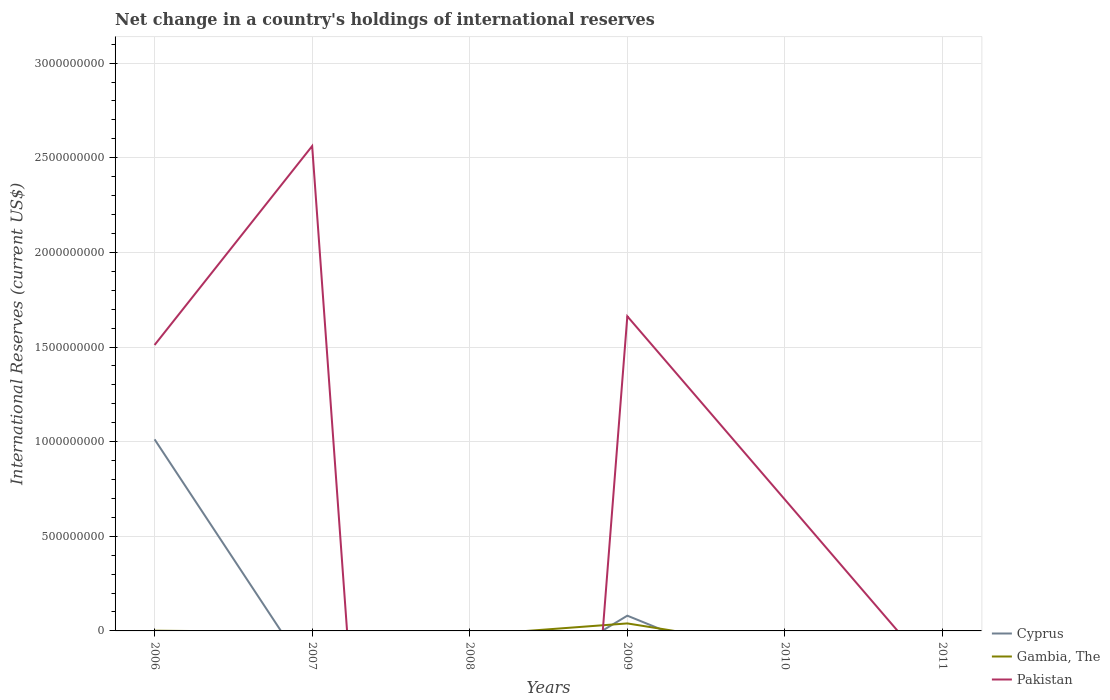Is the number of lines equal to the number of legend labels?
Provide a succinct answer. No. Across all years, what is the maximum international reserves in Pakistan?
Provide a succinct answer. 0. What is the total international reserves in Pakistan in the graph?
Provide a short and direct response. 1.87e+09. What is the difference between the highest and the second highest international reserves in Cyprus?
Your response must be concise. 1.01e+09. What is the difference between the highest and the lowest international reserves in Pakistan?
Your answer should be very brief. 3. Is the international reserves in Gambia, The strictly greater than the international reserves in Cyprus over the years?
Give a very brief answer. No. Does the graph contain any zero values?
Make the answer very short. Yes. How many legend labels are there?
Your answer should be compact. 3. How are the legend labels stacked?
Offer a very short reply. Vertical. What is the title of the graph?
Your response must be concise. Net change in a country's holdings of international reserves. Does "Congo (Democratic)" appear as one of the legend labels in the graph?
Your answer should be compact. No. What is the label or title of the X-axis?
Provide a short and direct response. Years. What is the label or title of the Y-axis?
Ensure brevity in your answer.  International Reserves (current US$). What is the International Reserves (current US$) in Cyprus in 2006?
Offer a terse response. 1.01e+09. What is the International Reserves (current US$) of Gambia, The in 2006?
Your response must be concise. 1.14e+06. What is the International Reserves (current US$) of Pakistan in 2006?
Your answer should be compact. 1.51e+09. What is the International Reserves (current US$) in Cyprus in 2007?
Provide a succinct answer. 0. What is the International Reserves (current US$) of Gambia, The in 2007?
Give a very brief answer. 0. What is the International Reserves (current US$) in Pakistan in 2007?
Your response must be concise. 2.56e+09. What is the International Reserves (current US$) of Cyprus in 2009?
Offer a very short reply. 8.05e+07. What is the International Reserves (current US$) in Gambia, The in 2009?
Ensure brevity in your answer.  3.96e+07. What is the International Reserves (current US$) of Pakistan in 2009?
Your answer should be very brief. 1.66e+09. What is the International Reserves (current US$) in Cyprus in 2010?
Keep it short and to the point. 0. What is the International Reserves (current US$) of Pakistan in 2010?
Ensure brevity in your answer.  6.94e+08. What is the International Reserves (current US$) of Cyprus in 2011?
Your response must be concise. 0. What is the International Reserves (current US$) of Gambia, The in 2011?
Offer a very short reply. 0. Across all years, what is the maximum International Reserves (current US$) in Cyprus?
Keep it short and to the point. 1.01e+09. Across all years, what is the maximum International Reserves (current US$) in Gambia, The?
Offer a very short reply. 3.96e+07. Across all years, what is the maximum International Reserves (current US$) in Pakistan?
Provide a succinct answer. 2.56e+09. Across all years, what is the minimum International Reserves (current US$) of Cyprus?
Offer a very short reply. 0. Across all years, what is the minimum International Reserves (current US$) in Pakistan?
Your answer should be compact. 0. What is the total International Reserves (current US$) in Cyprus in the graph?
Your answer should be compact. 1.09e+09. What is the total International Reserves (current US$) of Gambia, The in the graph?
Ensure brevity in your answer.  4.07e+07. What is the total International Reserves (current US$) of Pakistan in the graph?
Ensure brevity in your answer.  6.43e+09. What is the difference between the International Reserves (current US$) in Pakistan in 2006 and that in 2007?
Offer a terse response. -1.05e+09. What is the difference between the International Reserves (current US$) of Cyprus in 2006 and that in 2009?
Your response must be concise. 9.32e+08. What is the difference between the International Reserves (current US$) in Gambia, The in 2006 and that in 2009?
Offer a very short reply. -3.85e+07. What is the difference between the International Reserves (current US$) in Pakistan in 2006 and that in 2009?
Offer a very short reply. -1.52e+08. What is the difference between the International Reserves (current US$) in Pakistan in 2006 and that in 2010?
Provide a short and direct response. 8.17e+08. What is the difference between the International Reserves (current US$) of Pakistan in 2007 and that in 2009?
Offer a terse response. 8.99e+08. What is the difference between the International Reserves (current US$) in Pakistan in 2007 and that in 2010?
Keep it short and to the point. 1.87e+09. What is the difference between the International Reserves (current US$) of Pakistan in 2009 and that in 2010?
Your response must be concise. 9.69e+08. What is the difference between the International Reserves (current US$) in Cyprus in 2006 and the International Reserves (current US$) in Pakistan in 2007?
Provide a short and direct response. -1.55e+09. What is the difference between the International Reserves (current US$) of Gambia, The in 2006 and the International Reserves (current US$) of Pakistan in 2007?
Your answer should be compact. -2.56e+09. What is the difference between the International Reserves (current US$) of Cyprus in 2006 and the International Reserves (current US$) of Gambia, The in 2009?
Offer a very short reply. 9.73e+08. What is the difference between the International Reserves (current US$) of Cyprus in 2006 and the International Reserves (current US$) of Pakistan in 2009?
Provide a short and direct response. -6.50e+08. What is the difference between the International Reserves (current US$) in Gambia, The in 2006 and the International Reserves (current US$) in Pakistan in 2009?
Offer a terse response. -1.66e+09. What is the difference between the International Reserves (current US$) in Cyprus in 2006 and the International Reserves (current US$) in Pakistan in 2010?
Offer a terse response. 3.18e+08. What is the difference between the International Reserves (current US$) of Gambia, The in 2006 and the International Reserves (current US$) of Pakistan in 2010?
Your response must be concise. -6.93e+08. What is the difference between the International Reserves (current US$) of Cyprus in 2009 and the International Reserves (current US$) of Pakistan in 2010?
Your answer should be compact. -6.13e+08. What is the difference between the International Reserves (current US$) in Gambia, The in 2009 and the International Reserves (current US$) in Pakistan in 2010?
Provide a succinct answer. -6.54e+08. What is the average International Reserves (current US$) in Cyprus per year?
Offer a terse response. 1.82e+08. What is the average International Reserves (current US$) of Gambia, The per year?
Ensure brevity in your answer.  6.79e+06. What is the average International Reserves (current US$) in Pakistan per year?
Your answer should be very brief. 1.07e+09. In the year 2006, what is the difference between the International Reserves (current US$) in Cyprus and International Reserves (current US$) in Gambia, The?
Ensure brevity in your answer.  1.01e+09. In the year 2006, what is the difference between the International Reserves (current US$) in Cyprus and International Reserves (current US$) in Pakistan?
Give a very brief answer. -4.98e+08. In the year 2006, what is the difference between the International Reserves (current US$) in Gambia, The and International Reserves (current US$) in Pakistan?
Ensure brevity in your answer.  -1.51e+09. In the year 2009, what is the difference between the International Reserves (current US$) of Cyprus and International Reserves (current US$) of Gambia, The?
Offer a very short reply. 4.09e+07. In the year 2009, what is the difference between the International Reserves (current US$) in Cyprus and International Reserves (current US$) in Pakistan?
Make the answer very short. -1.58e+09. In the year 2009, what is the difference between the International Reserves (current US$) of Gambia, The and International Reserves (current US$) of Pakistan?
Provide a short and direct response. -1.62e+09. What is the ratio of the International Reserves (current US$) of Pakistan in 2006 to that in 2007?
Your response must be concise. 0.59. What is the ratio of the International Reserves (current US$) in Cyprus in 2006 to that in 2009?
Your response must be concise. 12.57. What is the ratio of the International Reserves (current US$) of Gambia, The in 2006 to that in 2009?
Offer a very short reply. 0.03. What is the ratio of the International Reserves (current US$) of Pakistan in 2006 to that in 2009?
Give a very brief answer. 0.91. What is the ratio of the International Reserves (current US$) in Pakistan in 2006 to that in 2010?
Keep it short and to the point. 2.18. What is the ratio of the International Reserves (current US$) in Pakistan in 2007 to that in 2009?
Keep it short and to the point. 1.54. What is the ratio of the International Reserves (current US$) in Pakistan in 2007 to that in 2010?
Offer a very short reply. 3.69. What is the ratio of the International Reserves (current US$) of Pakistan in 2009 to that in 2010?
Your answer should be compact. 2.4. What is the difference between the highest and the second highest International Reserves (current US$) in Pakistan?
Provide a short and direct response. 8.99e+08. What is the difference between the highest and the lowest International Reserves (current US$) in Cyprus?
Offer a very short reply. 1.01e+09. What is the difference between the highest and the lowest International Reserves (current US$) in Gambia, The?
Your response must be concise. 3.96e+07. What is the difference between the highest and the lowest International Reserves (current US$) in Pakistan?
Your answer should be compact. 2.56e+09. 